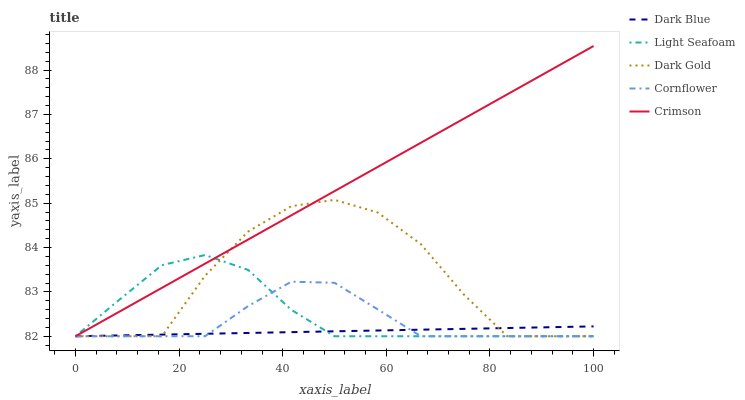Does Dark Blue have the minimum area under the curve?
Answer yes or no. Yes. Does Crimson have the maximum area under the curve?
Answer yes or no. Yes. Does Light Seafoam have the minimum area under the curve?
Answer yes or no. No. Does Light Seafoam have the maximum area under the curve?
Answer yes or no. No. Is Crimson the smoothest?
Answer yes or no. Yes. Is Dark Gold the roughest?
Answer yes or no. Yes. Is Dark Blue the smoothest?
Answer yes or no. No. Is Dark Blue the roughest?
Answer yes or no. No. Does Crimson have the lowest value?
Answer yes or no. Yes. Does Crimson have the highest value?
Answer yes or no. Yes. Does Light Seafoam have the highest value?
Answer yes or no. No. Does Dark Gold intersect Light Seafoam?
Answer yes or no. Yes. Is Dark Gold less than Light Seafoam?
Answer yes or no. No. Is Dark Gold greater than Light Seafoam?
Answer yes or no. No. 